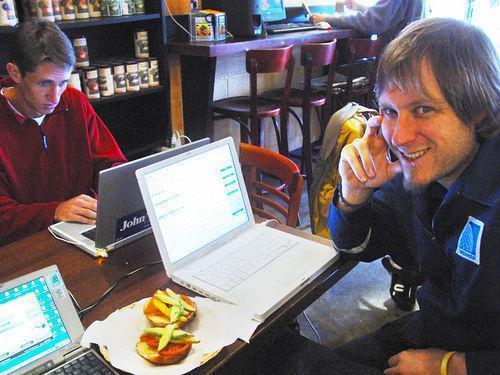How many empty chairs are in the photo?
Give a very brief answer. 4. How many people can be seen in the photo?
Give a very brief answer. 3. How many laptops are on the table?
Give a very brief answer. 3. How many men are at the table?
Give a very brief answer. 2. How many chairs can be seen at the counter in back?
Give a very brief answer. 3. How many people are at the counter?
Give a very brief answer. 1. 